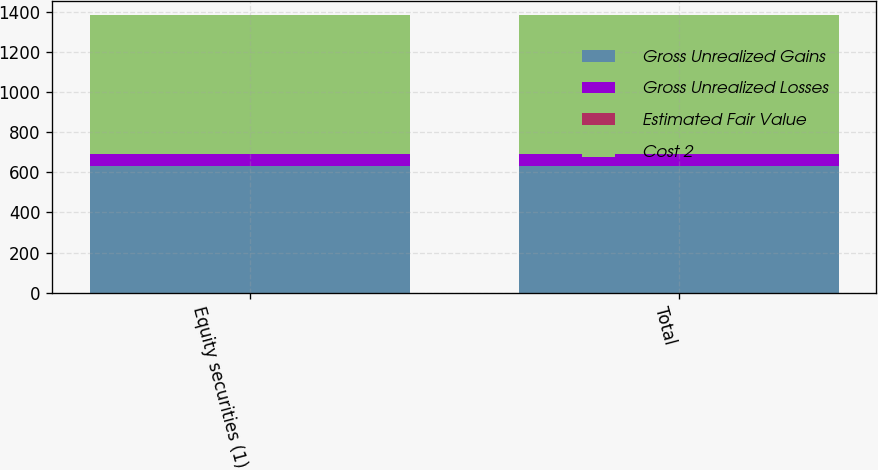Convert chart to OTSL. <chart><loc_0><loc_0><loc_500><loc_500><stacked_bar_chart><ecel><fcel>Equity securities (1)<fcel>Total<nl><fcel>Gross Unrealized Gains<fcel>630.3<fcel>630.3<nl><fcel>Gross Unrealized Losses<fcel>61.2<fcel>61.2<nl><fcel>Estimated Fair Value<fcel>0<fcel>0<nl><fcel>Cost 2<fcel>691.5<fcel>691.5<nl></chart> 